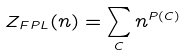<formula> <loc_0><loc_0><loc_500><loc_500>Z _ { F P L } ( n ) = \sum _ { C } n ^ { P ( C ) }</formula> 